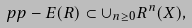Convert formula to latex. <formula><loc_0><loc_0><loc_500><loc_500>\ p p - E ( R ) \subset \cup _ { n \geq 0 } R ^ { n } ( X ) ,</formula> 